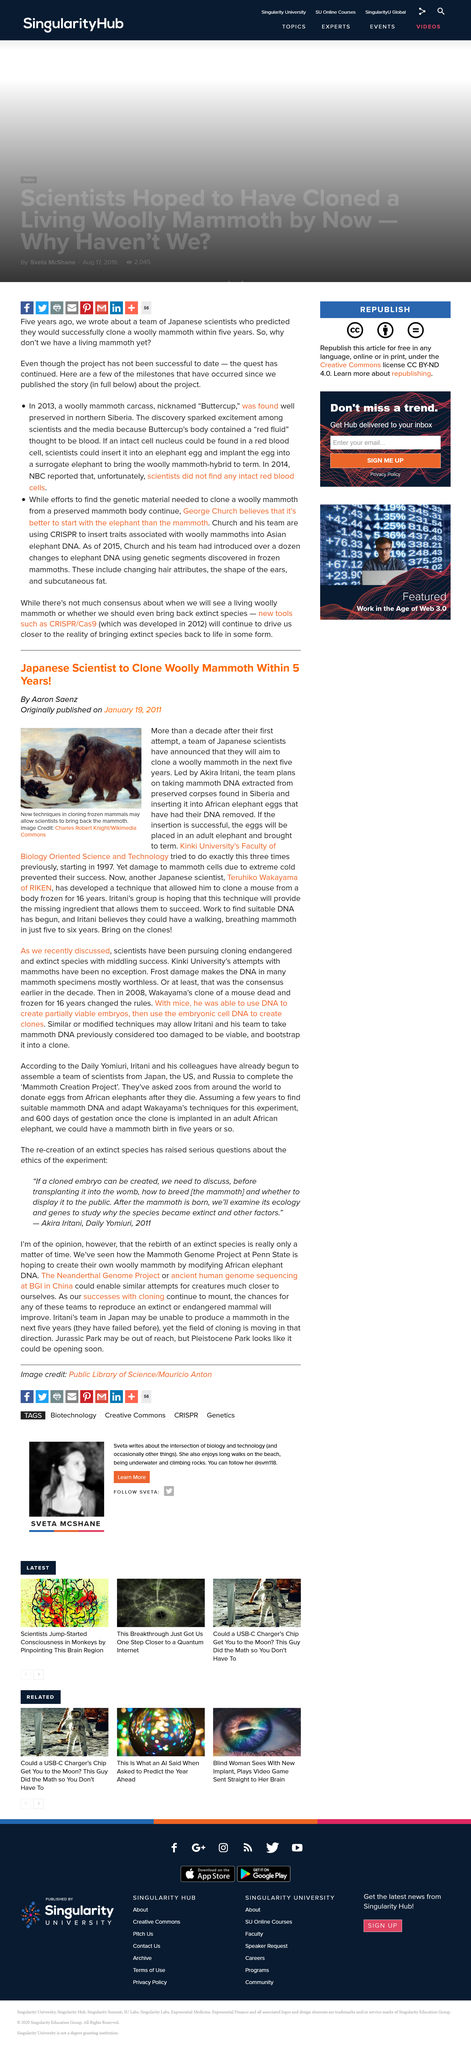Highlight a few significant elements in this photo. It is predicted that Japanese scientists will be able to clone the wool mammoth within the next 5 years. The Japanese team's first attempt at cloning a wool mammoth was made 14 years prior to the publication date. Dr. Teruhiko Wakayama, a renowned scientist, developed a breakthrough mouse cloning technique that has the potential to revolutionize the field of genetics and biotechnology. 